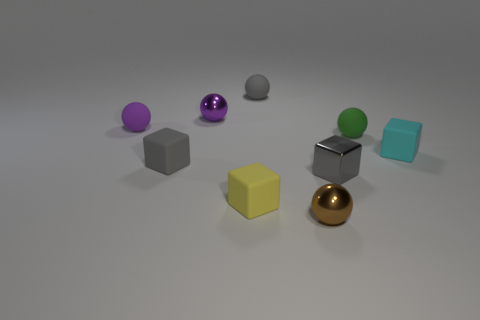How many other objects are there of the same color as the tiny shiny block?
Keep it short and to the point. 2. What size is the purple shiny sphere?
Offer a terse response. Small. Is the number of brown spheres behind the brown thing greater than the number of metal things that are behind the small cyan matte thing?
Make the answer very short. No. What number of rubber cubes are right of the small gray matte object that is behind the cyan thing?
Make the answer very short. 1. Is the shape of the tiny gray matte object in front of the green sphere the same as  the green thing?
Provide a succinct answer. No. What material is the small green thing that is the same shape as the brown thing?
Offer a terse response. Rubber. How many cyan matte blocks are the same size as the gray shiny object?
Provide a succinct answer. 1. There is a rubber sphere that is on the right side of the yellow rubber thing and in front of the gray rubber sphere; what color is it?
Offer a terse response. Green. Is the number of objects less than the number of shiny spheres?
Ensure brevity in your answer.  No. Is the color of the metallic cube the same as the tiny metal sphere behind the small green thing?
Ensure brevity in your answer.  No. 